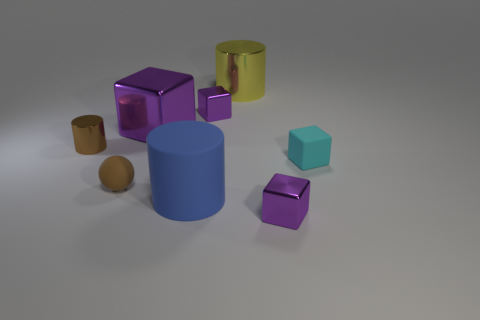Subtract all red spheres. How many purple cubes are left? 3 Add 1 large purple things. How many objects exist? 9 Subtract all cylinders. How many objects are left? 5 Subtract all large blue matte blocks. Subtract all brown matte objects. How many objects are left? 7 Add 5 tiny things. How many tiny things are left? 10 Add 1 small cyan things. How many small cyan things exist? 2 Subtract 0 blue balls. How many objects are left? 8 